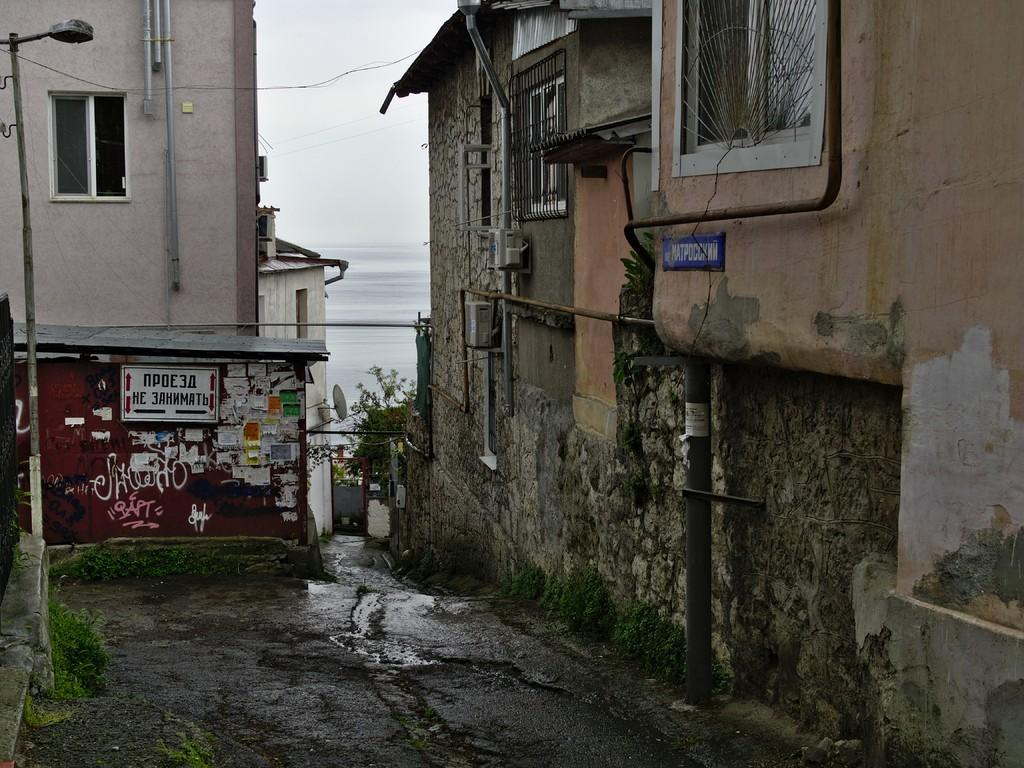What type of structures can be seen in the image? There are buildings in the image. What other natural elements are present in the image? There are trees in the image. What can be seen in the background of the image? The sky is visible in the background of the image. What type of honey is being harvested from the trees in the image? There is no honey or honey harvesting activity present in the image; it features buildings and trees. 